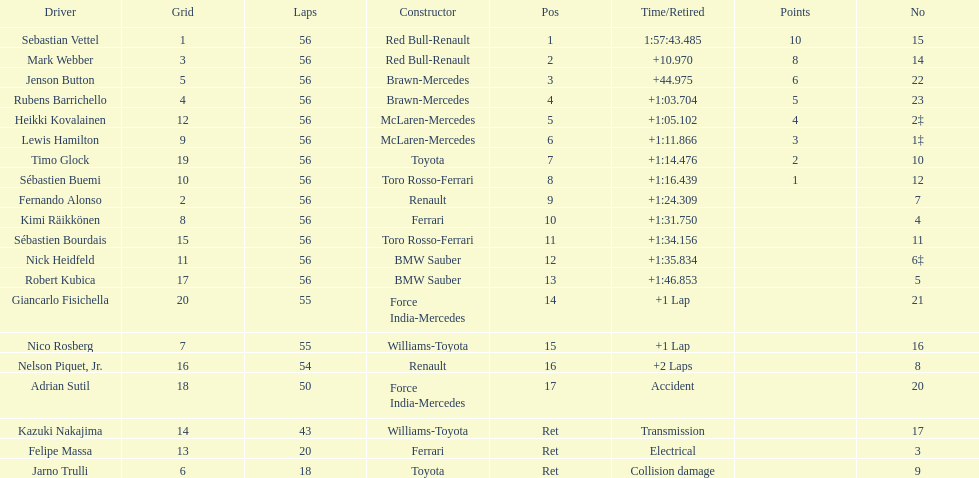Would you be able to parse every entry in this table? {'header': ['Driver', 'Grid', 'Laps', 'Constructor', 'Pos', 'Time/Retired', 'Points', 'No'], 'rows': [['Sebastian Vettel', '1', '56', 'Red Bull-Renault', '1', '1:57:43.485', '10', '15'], ['Mark Webber', '3', '56', 'Red Bull-Renault', '2', '+10.970', '8', '14'], ['Jenson Button', '5', '56', 'Brawn-Mercedes', '3', '+44.975', '6', '22'], ['Rubens Barrichello', '4', '56', 'Brawn-Mercedes', '4', '+1:03.704', '5', '23'], ['Heikki Kovalainen', '12', '56', 'McLaren-Mercedes', '5', '+1:05.102', '4', '2‡'], ['Lewis Hamilton', '9', '56', 'McLaren-Mercedes', '6', '+1:11.866', '3', '1‡'], ['Timo Glock', '19', '56', 'Toyota', '7', '+1:14.476', '2', '10'], ['Sébastien Buemi', '10', '56', 'Toro Rosso-Ferrari', '8', '+1:16.439', '1', '12'], ['Fernando Alonso', '2', '56', 'Renault', '9', '+1:24.309', '', '7'], ['Kimi Räikkönen', '8', '56', 'Ferrari', '10', '+1:31.750', '', '4'], ['Sébastien Bourdais', '15', '56', 'Toro Rosso-Ferrari', '11', '+1:34.156', '', '11'], ['Nick Heidfeld', '11', '56', 'BMW Sauber', '12', '+1:35.834', '', '6‡'], ['Robert Kubica', '17', '56', 'BMW Sauber', '13', '+1:46.853', '', '5'], ['Giancarlo Fisichella', '20', '55', 'Force India-Mercedes', '14', '+1 Lap', '', '21'], ['Nico Rosberg', '7', '55', 'Williams-Toyota', '15', '+1 Lap', '', '16'], ['Nelson Piquet, Jr.', '16', '54', 'Renault', '16', '+2 Laps', '', '8'], ['Adrian Sutil', '18', '50', 'Force India-Mercedes', '17', 'Accident', '', '20'], ['Kazuki Nakajima', '14', '43', 'Williams-Toyota', 'Ret', 'Transmission', '', '17'], ['Felipe Massa', '13', '20', 'Ferrari', 'Ret', 'Electrical', '', '3'], ['Jarno Trulli', '6', '18', 'Toyota', 'Ret', 'Collision damage', '', '9']]} What name is just previous to kazuki nakjima on the list? Adrian Sutil. 